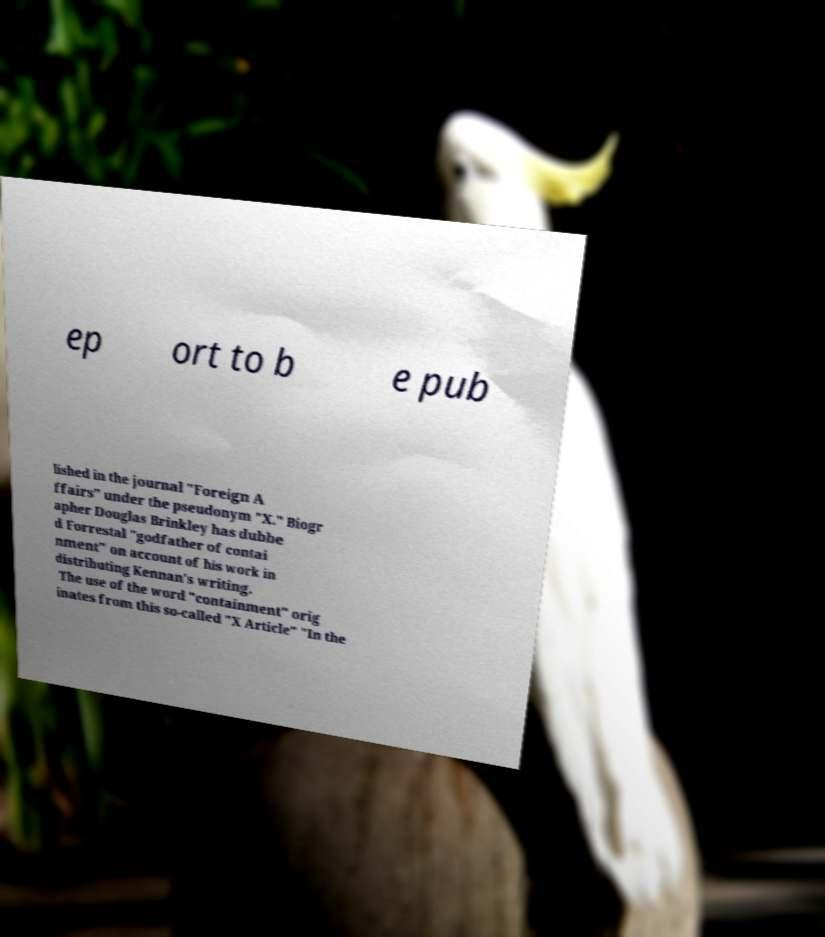What messages or text are displayed in this image? I need them in a readable, typed format. ep ort to b e pub lished in the journal "Foreign A ffairs" under the pseudonym "X." Biogr apher Douglas Brinkley has dubbe d Forrestal "godfather of contai nment" on account of his work in distributing Kennan's writing. The use of the word "containment" orig inates from this so-called "X Article" "In the 